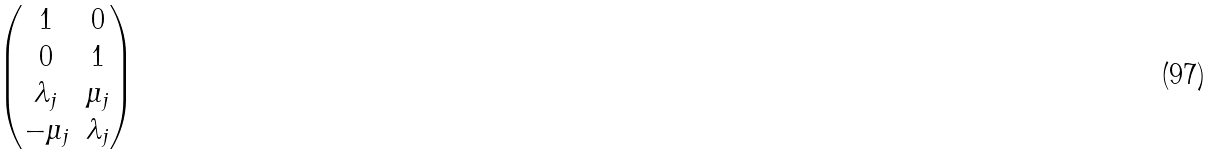<formula> <loc_0><loc_0><loc_500><loc_500>\begin{pmatrix} 1 & 0 \\ 0 & 1 \\ \lambda _ { j } & \mu _ { j } \\ - \mu _ { j } & \lambda _ { j } \end{pmatrix}</formula> 